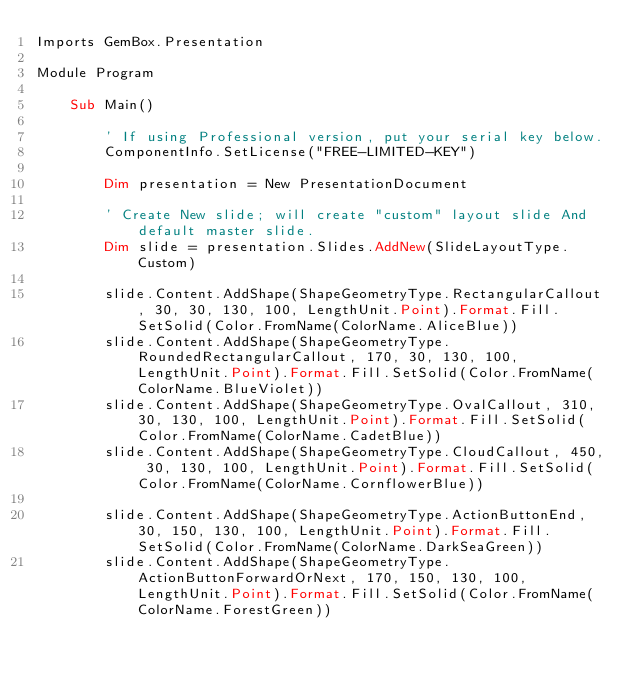<code> <loc_0><loc_0><loc_500><loc_500><_VisualBasic_>Imports GemBox.Presentation

Module Program

    Sub Main()

        ' If using Professional version, put your serial key below.
        ComponentInfo.SetLicense("FREE-LIMITED-KEY")

        Dim presentation = New PresentationDocument

        ' Create New slide; will create "custom" layout slide And default master slide.
        Dim slide = presentation.Slides.AddNew(SlideLayoutType.Custom)

        slide.Content.AddShape(ShapeGeometryType.RectangularCallout, 30, 30, 130, 100, LengthUnit.Point).Format.Fill.SetSolid(Color.FromName(ColorName.AliceBlue))
        slide.Content.AddShape(ShapeGeometryType.RoundedRectangularCallout, 170, 30, 130, 100, LengthUnit.Point).Format.Fill.SetSolid(Color.FromName(ColorName.BlueViolet))
        slide.Content.AddShape(ShapeGeometryType.OvalCallout, 310, 30, 130, 100, LengthUnit.Point).Format.Fill.SetSolid(Color.FromName(ColorName.CadetBlue))
        slide.Content.AddShape(ShapeGeometryType.CloudCallout, 450, 30, 130, 100, LengthUnit.Point).Format.Fill.SetSolid(Color.FromName(ColorName.CornflowerBlue))

        slide.Content.AddShape(ShapeGeometryType.ActionButtonEnd, 30, 150, 130, 100, LengthUnit.Point).Format.Fill.SetSolid(Color.FromName(ColorName.DarkSeaGreen))
        slide.Content.AddShape(ShapeGeometryType.ActionButtonForwardOrNext, 170, 150, 130, 100, LengthUnit.Point).Format.Fill.SetSolid(Color.FromName(ColorName.ForestGreen))</code> 